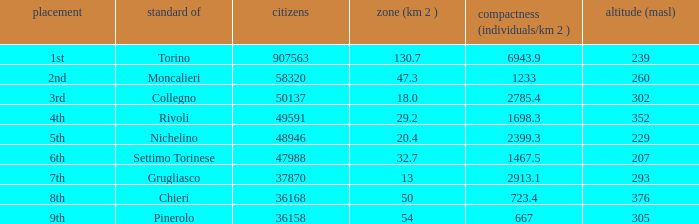What is the name of the 9th ranked common? Pinerolo. 